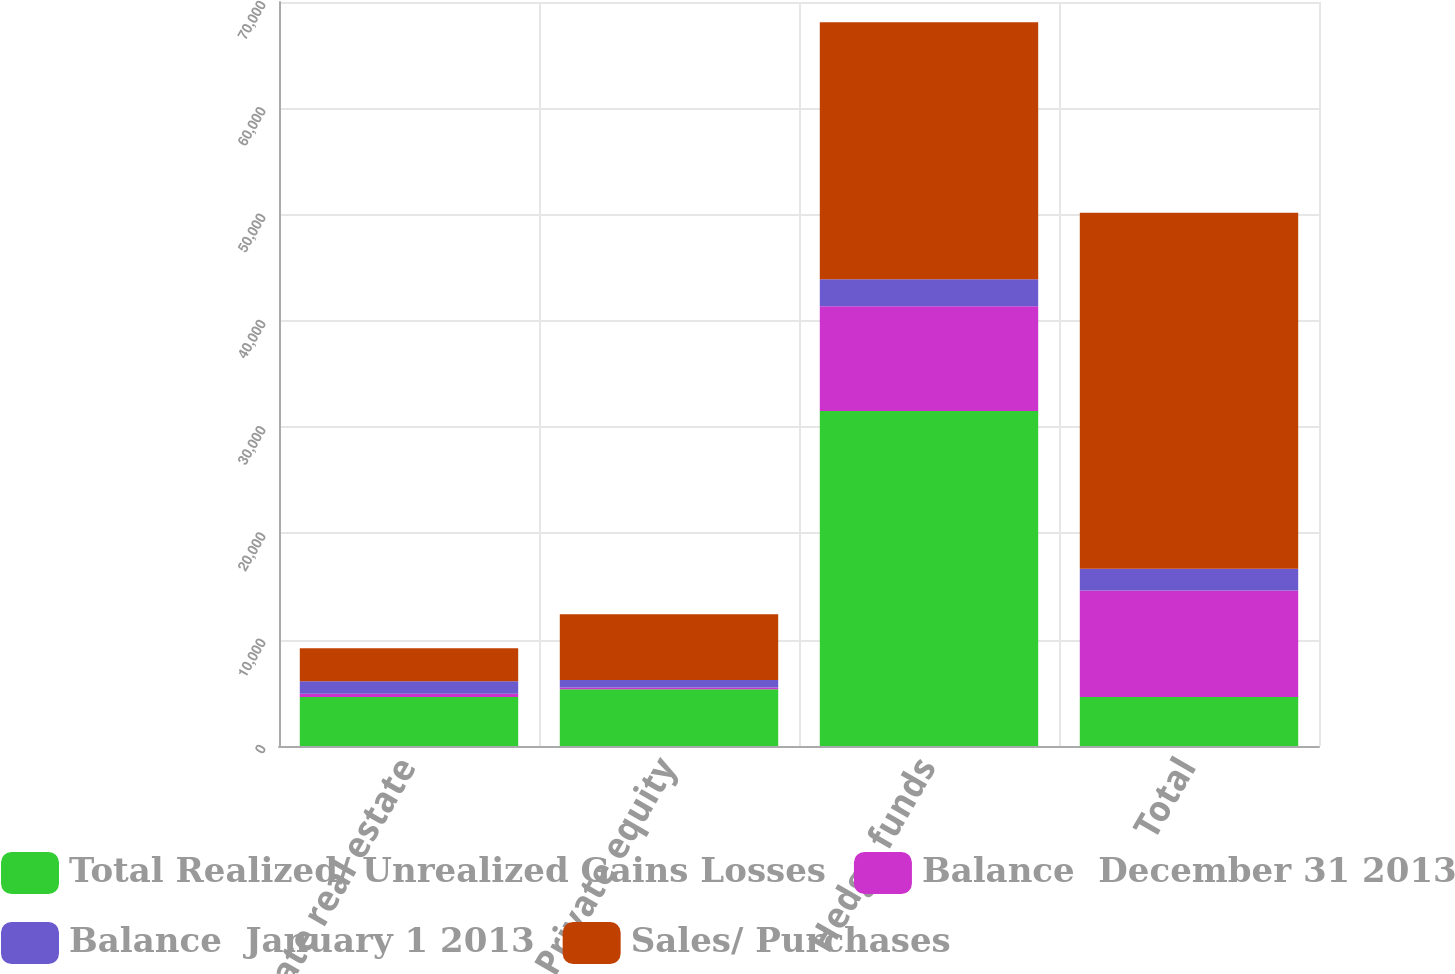Convert chart to OTSL. <chart><loc_0><loc_0><loc_500><loc_500><stacked_bar_chart><ecel><fcel>Private real estate<fcel>Private equity<fcel>Hedge funds<fcel>Total<nl><fcel>Total Realized/ Unrealized Gains Losses<fcel>4603<fcel>5347<fcel>31509<fcel>4603<nl><fcel>Balance  December 31 2013<fcel>308<fcel>165<fcel>9873<fcel>10016<nl><fcel>Balance  January 1 2013<fcel>1172<fcel>687<fcel>2538<fcel>2053<nl><fcel>Sales/ Purchases<fcel>3123<fcel>6199<fcel>24174<fcel>33496<nl></chart> 